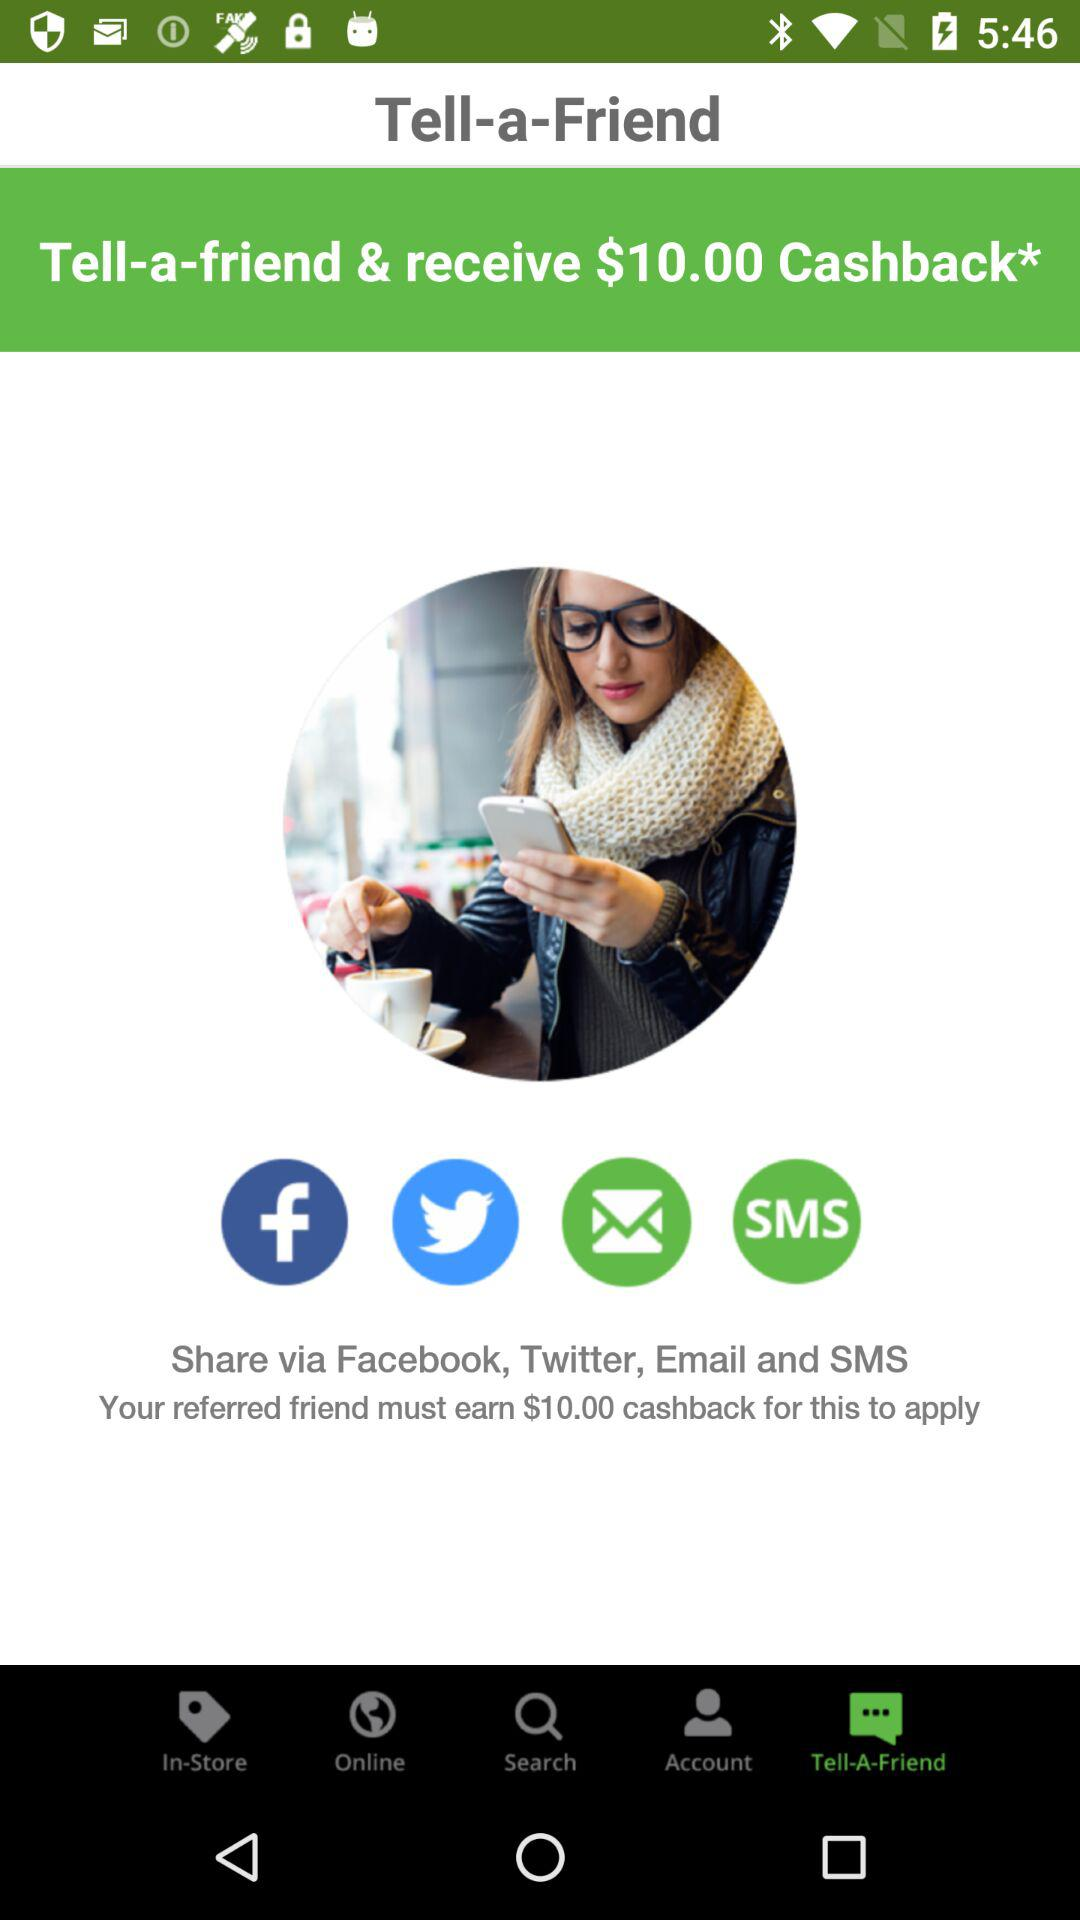Which tab has been selected? The tab that has been selected is "Tell-A-Friend". 